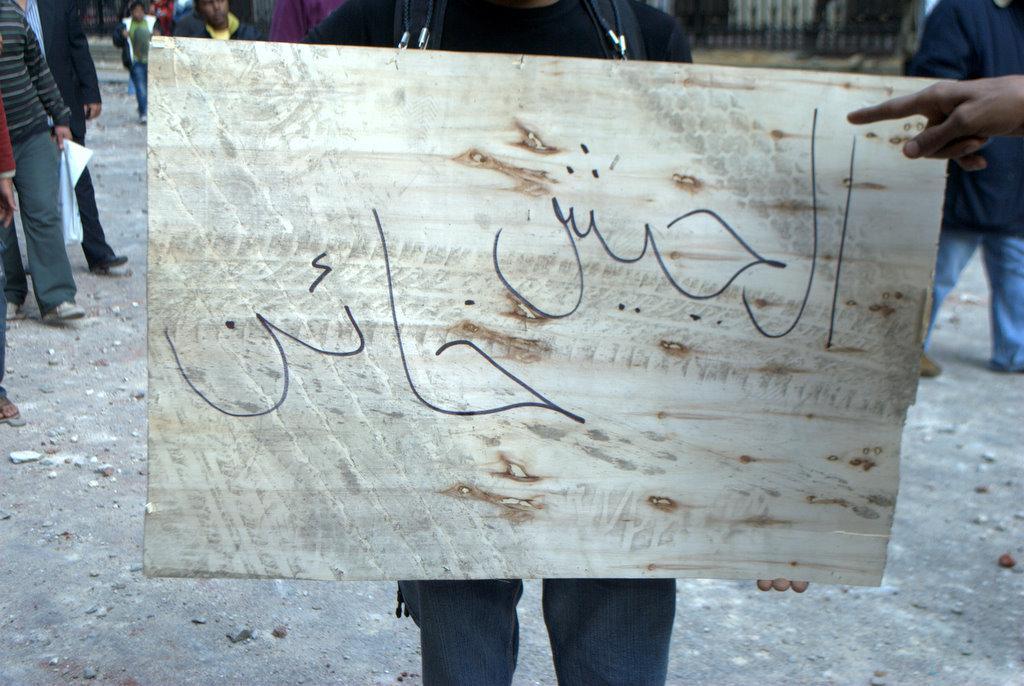Can you describe this image briefly? In this image I can see a person holding a board which is in white color. Background I can see few other people some are standing and some are walking. I can also see black color railing. 